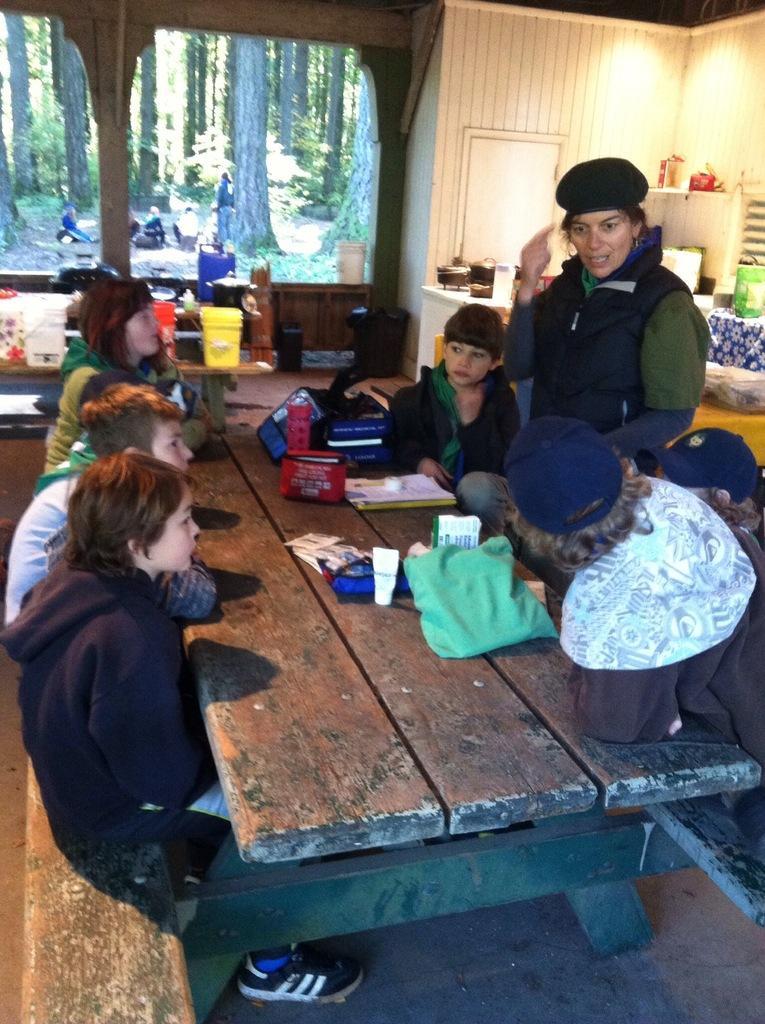Can you describe this image briefly? In the center of the image there is a table on which there are objects. There are people sitting on the bench. In the background of the image there is a glass window through which we can see trees. There is a table on which there are objects. To the right side of the image there is wall and there are some objects. 